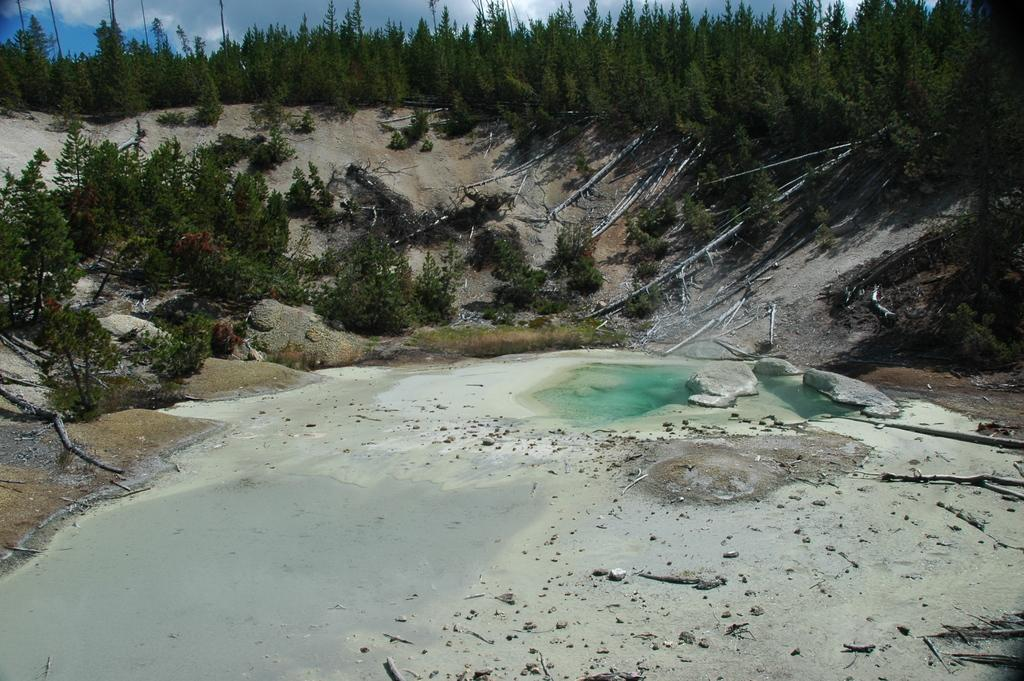What type of vegetation is present in the image? There are green trees in the image. What natural element can be seen alongside the trees? There is water visible in the image. What degree does the robin have in the image? There is no robin present in the image, so it cannot be determined if it has a degree or not. 